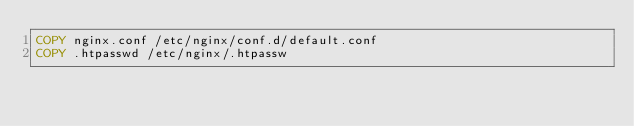Convert code to text. <code><loc_0><loc_0><loc_500><loc_500><_Dockerfile_>COPY nginx.conf /etc/nginx/conf.d/default.conf
COPY .htpasswd /etc/nginx/.htpassw</code> 